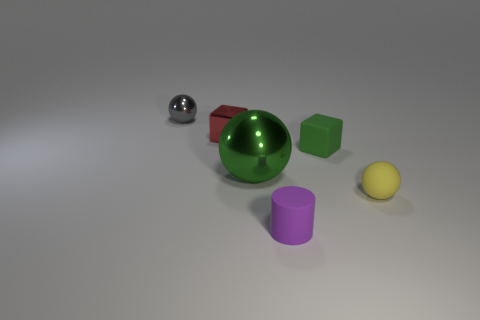Is there anything in the image that suggests size or scale? There are no definitive indicators of size or scale, such as familiar objects or a background with discernible features. The objects are displayed on a uniform surface with a gradient, and without additional context, it's challenging to determine their actual sizes. 